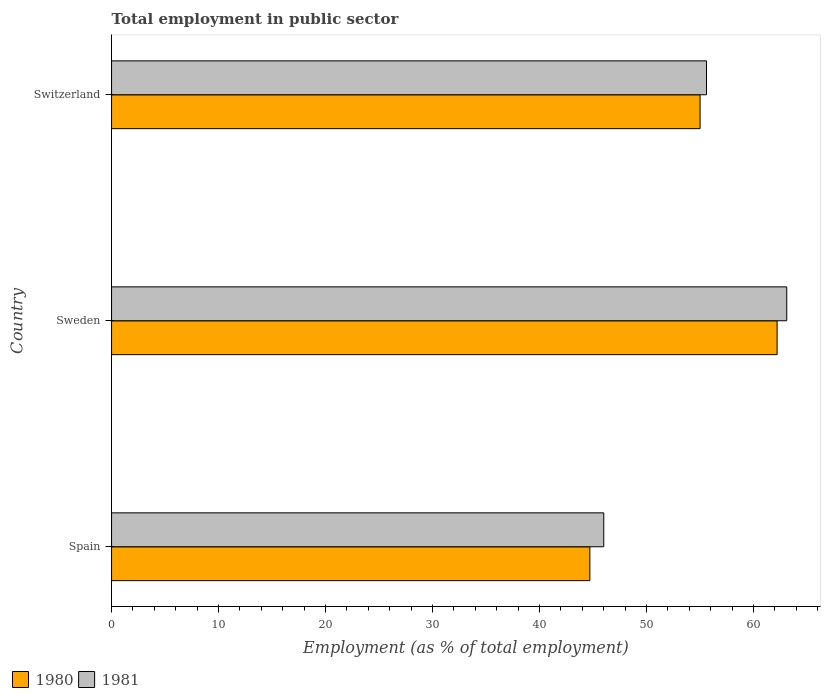How many different coloured bars are there?
Offer a terse response. 2. How many groups of bars are there?
Make the answer very short. 3. Are the number of bars per tick equal to the number of legend labels?
Keep it short and to the point. Yes. How many bars are there on the 3rd tick from the top?
Your answer should be very brief. 2. How many bars are there on the 2nd tick from the bottom?
Your answer should be very brief. 2. What is the label of the 1st group of bars from the top?
Your answer should be compact. Switzerland. In how many cases, is the number of bars for a given country not equal to the number of legend labels?
Offer a terse response. 0. What is the employment in public sector in 1981 in Switzerland?
Your response must be concise. 55.6. Across all countries, what is the maximum employment in public sector in 1981?
Offer a very short reply. 63.1. Across all countries, what is the minimum employment in public sector in 1981?
Provide a succinct answer. 46. In which country was the employment in public sector in 1980 minimum?
Make the answer very short. Spain. What is the total employment in public sector in 1981 in the graph?
Offer a very short reply. 164.7. What is the difference between the employment in public sector in 1981 in Spain and that in Sweden?
Your response must be concise. -17.1. What is the difference between the employment in public sector in 1981 in Spain and the employment in public sector in 1980 in Sweden?
Ensure brevity in your answer.  -16.2. What is the average employment in public sector in 1981 per country?
Give a very brief answer. 54.9. What is the difference between the employment in public sector in 1980 and employment in public sector in 1981 in Switzerland?
Provide a short and direct response. -0.6. What is the ratio of the employment in public sector in 1981 in Sweden to that in Switzerland?
Offer a very short reply. 1.13. What is the difference between the highest and the second highest employment in public sector in 1980?
Ensure brevity in your answer.  7.2. In how many countries, is the employment in public sector in 1980 greater than the average employment in public sector in 1980 taken over all countries?
Your response must be concise. 2. What does the 1st bar from the top in Sweden represents?
Your response must be concise. 1981. What does the 2nd bar from the bottom in Sweden represents?
Ensure brevity in your answer.  1981. How many countries are there in the graph?
Give a very brief answer. 3. What is the difference between two consecutive major ticks on the X-axis?
Your response must be concise. 10. Does the graph contain grids?
Your answer should be compact. No. Where does the legend appear in the graph?
Provide a succinct answer. Bottom left. What is the title of the graph?
Provide a succinct answer. Total employment in public sector. What is the label or title of the X-axis?
Give a very brief answer. Employment (as % of total employment). What is the label or title of the Y-axis?
Offer a very short reply. Country. What is the Employment (as % of total employment) of 1980 in Spain?
Offer a very short reply. 44.7. What is the Employment (as % of total employment) of 1981 in Spain?
Give a very brief answer. 46. What is the Employment (as % of total employment) in 1980 in Sweden?
Your answer should be very brief. 62.2. What is the Employment (as % of total employment) in 1981 in Sweden?
Provide a succinct answer. 63.1. What is the Employment (as % of total employment) in 1981 in Switzerland?
Your answer should be compact. 55.6. Across all countries, what is the maximum Employment (as % of total employment) of 1980?
Keep it short and to the point. 62.2. Across all countries, what is the maximum Employment (as % of total employment) in 1981?
Provide a succinct answer. 63.1. Across all countries, what is the minimum Employment (as % of total employment) in 1980?
Your response must be concise. 44.7. Across all countries, what is the minimum Employment (as % of total employment) of 1981?
Your response must be concise. 46. What is the total Employment (as % of total employment) in 1980 in the graph?
Make the answer very short. 161.9. What is the total Employment (as % of total employment) of 1981 in the graph?
Give a very brief answer. 164.7. What is the difference between the Employment (as % of total employment) of 1980 in Spain and that in Sweden?
Keep it short and to the point. -17.5. What is the difference between the Employment (as % of total employment) of 1981 in Spain and that in Sweden?
Offer a terse response. -17.1. What is the difference between the Employment (as % of total employment) in 1980 in Spain and that in Switzerland?
Keep it short and to the point. -10.3. What is the difference between the Employment (as % of total employment) of 1980 in Sweden and that in Switzerland?
Provide a short and direct response. 7.2. What is the difference between the Employment (as % of total employment) in 1981 in Sweden and that in Switzerland?
Provide a short and direct response. 7.5. What is the difference between the Employment (as % of total employment) in 1980 in Spain and the Employment (as % of total employment) in 1981 in Sweden?
Offer a very short reply. -18.4. What is the difference between the Employment (as % of total employment) in 1980 in Spain and the Employment (as % of total employment) in 1981 in Switzerland?
Provide a succinct answer. -10.9. What is the difference between the Employment (as % of total employment) in 1980 in Sweden and the Employment (as % of total employment) in 1981 in Switzerland?
Give a very brief answer. 6.6. What is the average Employment (as % of total employment) of 1980 per country?
Give a very brief answer. 53.97. What is the average Employment (as % of total employment) in 1981 per country?
Your answer should be compact. 54.9. What is the difference between the Employment (as % of total employment) of 1980 and Employment (as % of total employment) of 1981 in Spain?
Give a very brief answer. -1.3. What is the difference between the Employment (as % of total employment) of 1980 and Employment (as % of total employment) of 1981 in Sweden?
Keep it short and to the point. -0.9. What is the difference between the Employment (as % of total employment) of 1980 and Employment (as % of total employment) of 1981 in Switzerland?
Provide a short and direct response. -0.6. What is the ratio of the Employment (as % of total employment) in 1980 in Spain to that in Sweden?
Ensure brevity in your answer.  0.72. What is the ratio of the Employment (as % of total employment) in 1981 in Spain to that in Sweden?
Your answer should be compact. 0.73. What is the ratio of the Employment (as % of total employment) in 1980 in Spain to that in Switzerland?
Your answer should be very brief. 0.81. What is the ratio of the Employment (as % of total employment) of 1981 in Spain to that in Switzerland?
Keep it short and to the point. 0.83. What is the ratio of the Employment (as % of total employment) in 1980 in Sweden to that in Switzerland?
Offer a terse response. 1.13. What is the ratio of the Employment (as % of total employment) in 1981 in Sweden to that in Switzerland?
Your response must be concise. 1.13. What is the difference between the highest and the second highest Employment (as % of total employment) of 1980?
Offer a very short reply. 7.2. What is the difference between the highest and the lowest Employment (as % of total employment) of 1980?
Provide a short and direct response. 17.5. 